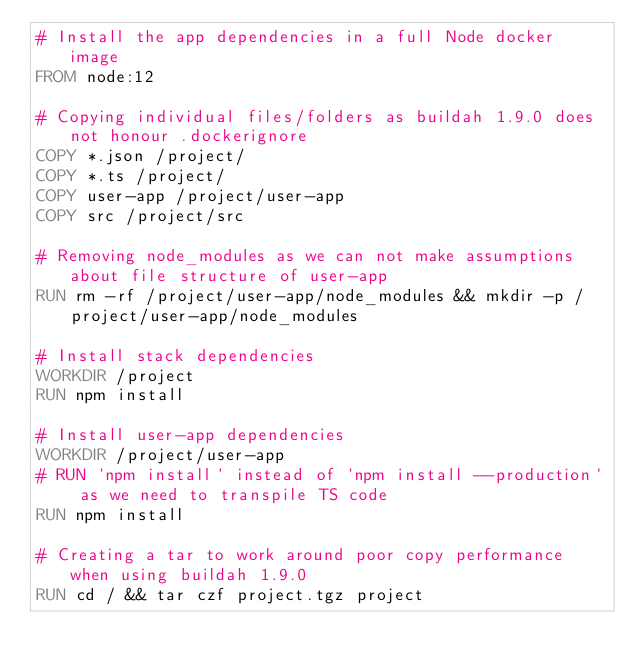Convert code to text. <code><loc_0><loc_0><loc_500><loc_500><_Dockerfile_># Install the app dependencies in a full Node docker image
FROM node:12

# Copying individual files/folders as buildah 1.9.0 does not honour .dockerignore
COPY *.json /project/
COPY *.ts /project/
COPY user-app /project/user-app
COPY src /project/src

# Removing node_modules as we can not make assumptions about file structure of user-app
RUN rm -rf /project/user-app/node_modules && mkdir -p /project/user-app/node_modules

# Install stack dependencies
WORKDIR /project
RUN npm install

# Install user-app dependencies
WORKDIR /project/user-app
# RUN `npm install` instead of `npm install --production` as we need to transpile TS code
RUN npm install

# Creating a tar to work around poor copy performance when using buildah 1.9.0
RUN cd / && tar czf project.tgz project
</code> 